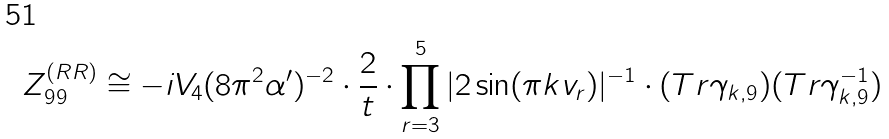<formula> <loc_0><loc_0><loc_500><loc_500>Z _ { 9 9 } ^ { ( R R ) } \cong - i V _ { 4 } ( 8 \pi ^ { 2 } \alpha ^ { \prime } ) ^ { - 2 } \cdot \frac { 2 } { t } \cdot \prod ^ { 5 } _ { r = 3 } | 2 \sin ( \pi k v _ { r } ) | ^ { - 1 } \cdot ( T r \gamma _ { k , 9 } ) ( T r \gamma _ { k , 9 } ^ { - 1 } )</formula> 